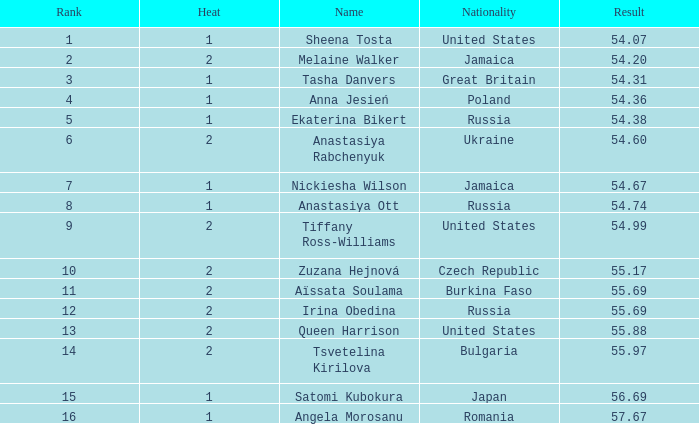Who has a Result of 54.67? Nickiesha Wilson. 